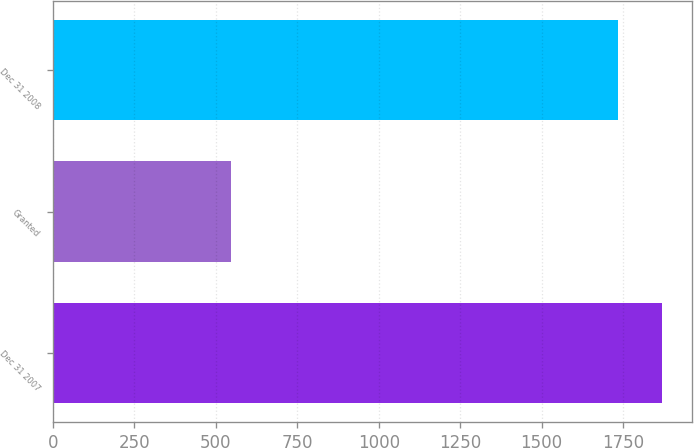Convert chart. <chart><loc_0><loc_0><loc_500><loc_500><bar_chart><fcel>Dec 31 2007<fcel>Granted<fcel>Dec 31 2008<nl><fcel>1869<fcel>548<fcel>1735<nl></chart> 